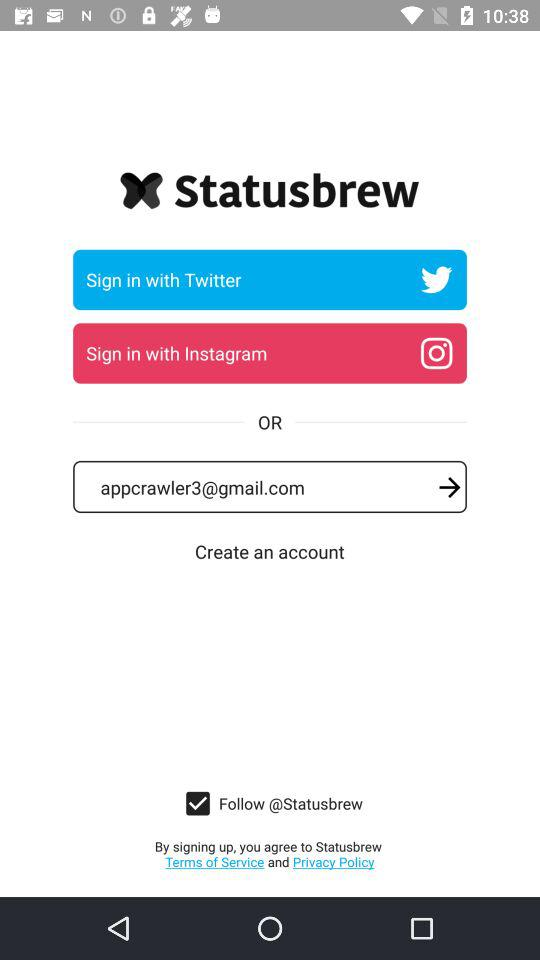What is the email address? The email address is appcrawler3@gmail.com. 